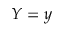<formula> <loc_0><loc_0><loc_500><loc_500>Y = y</formula> 